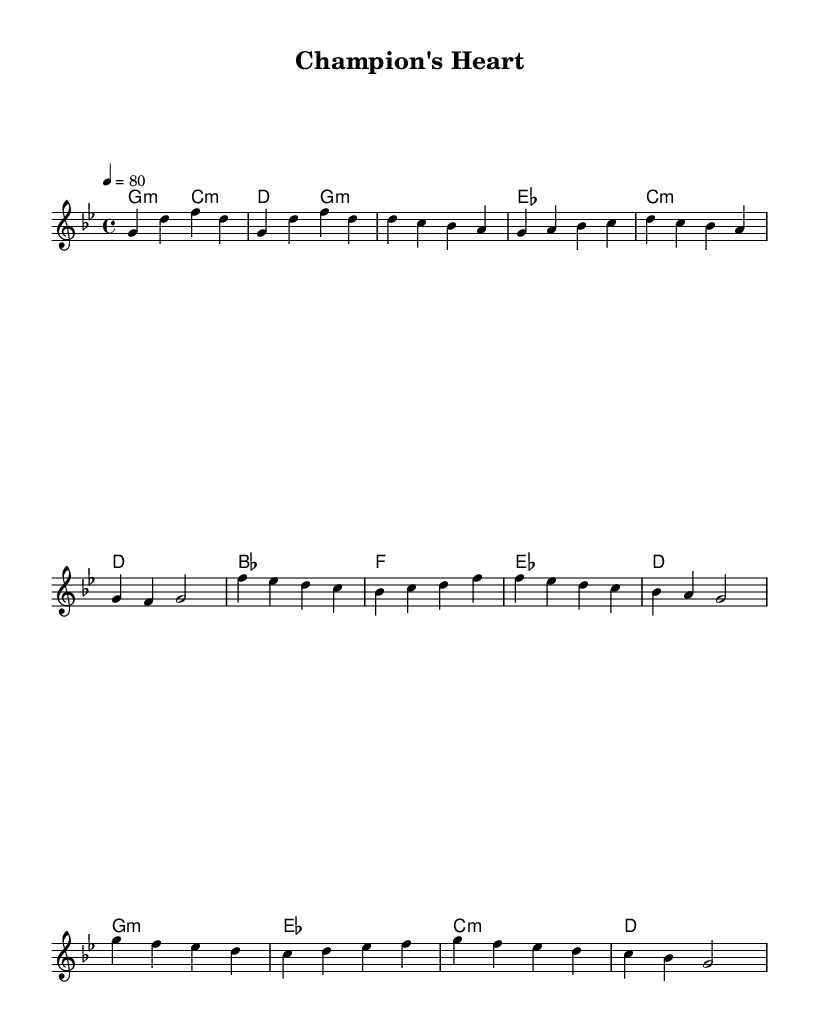What is the key signature of this music? The key signature is G minor, which is indicated by the two flats in the key signature (B flat and E flat).
Answer: G minor What is the time signature of this music? The time signature is 4/4, which can be identified by the notation appearing right after the key signature at the beginning of the score.
Answer: 4/4 What is the tempo marking for this piece? The tempo marking is 80, shown as '4 = 80' indicating the quarter note receives 80 beats per minute.
Answer: 80 What is the name of this piece? The title of the piece is "Champion's Heart," as indicated in the header section of the score.
Answer: Champion's Heart How many measures are in the chorus section? The chorus consists of four measures, identifiable by looking at the measure lines in that section of the melody.
Answer: 4 What type of chord is used in the introduction? The chords in the introduction are G minor and C minor, indicated by the chord symbols written above the melody in the corresponding measures.
Answer: G minor, C minor What is the feel of the pre-chorus compared to the verse? The pre-chorus has a heightened emotional feel due to changes in harmony and melody; it contrasts with the verse by building tension before the chorus, a usual characteristic of R&B songs.
Answer: Heightened emotional feel 